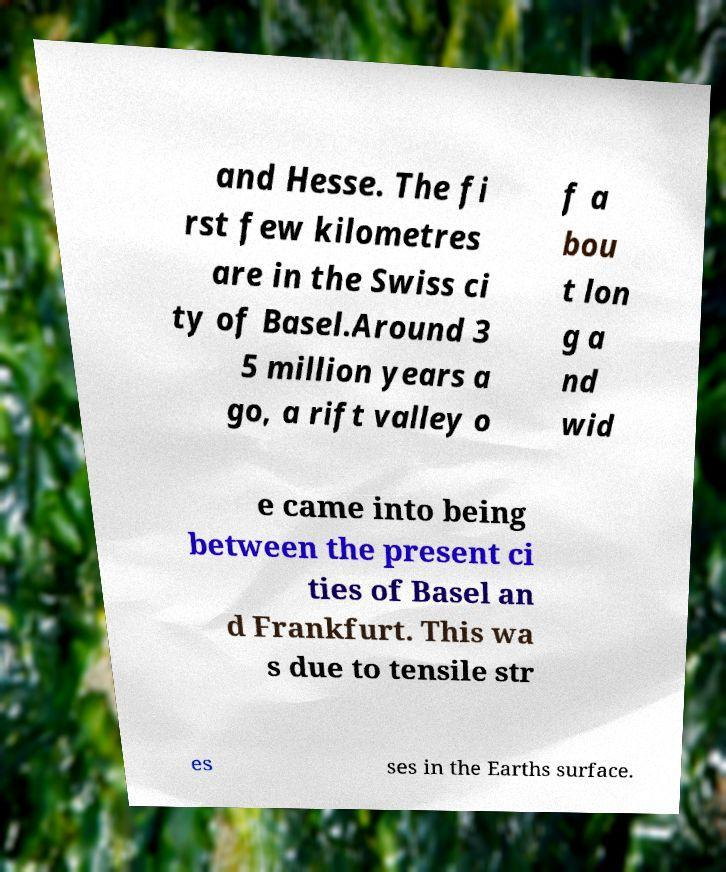What messages or text are displayed in this image? I need them in a readable, typed format. and Hesse. The fi rst few kilometres are in the Swiss ci ty of Basel.Around 3 5 million years a go, a rift valley o f a bou t lon g a nd wid e came into being between the present ci ties of Basel an d Frankfurt. This wa s due to tensile str es ses in the Earths surface. 